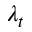<formula> <loc_0><loc_0><loc_500><loc_500>\lambda _ { t }</formula> 